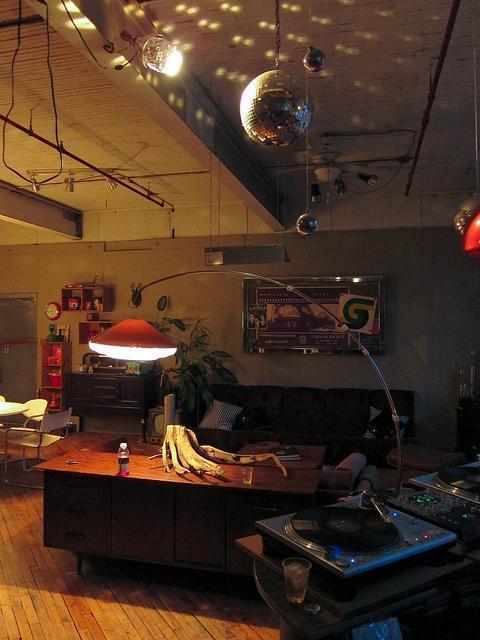How many of the people wear stripes?
Give a very brief answer. 0. 